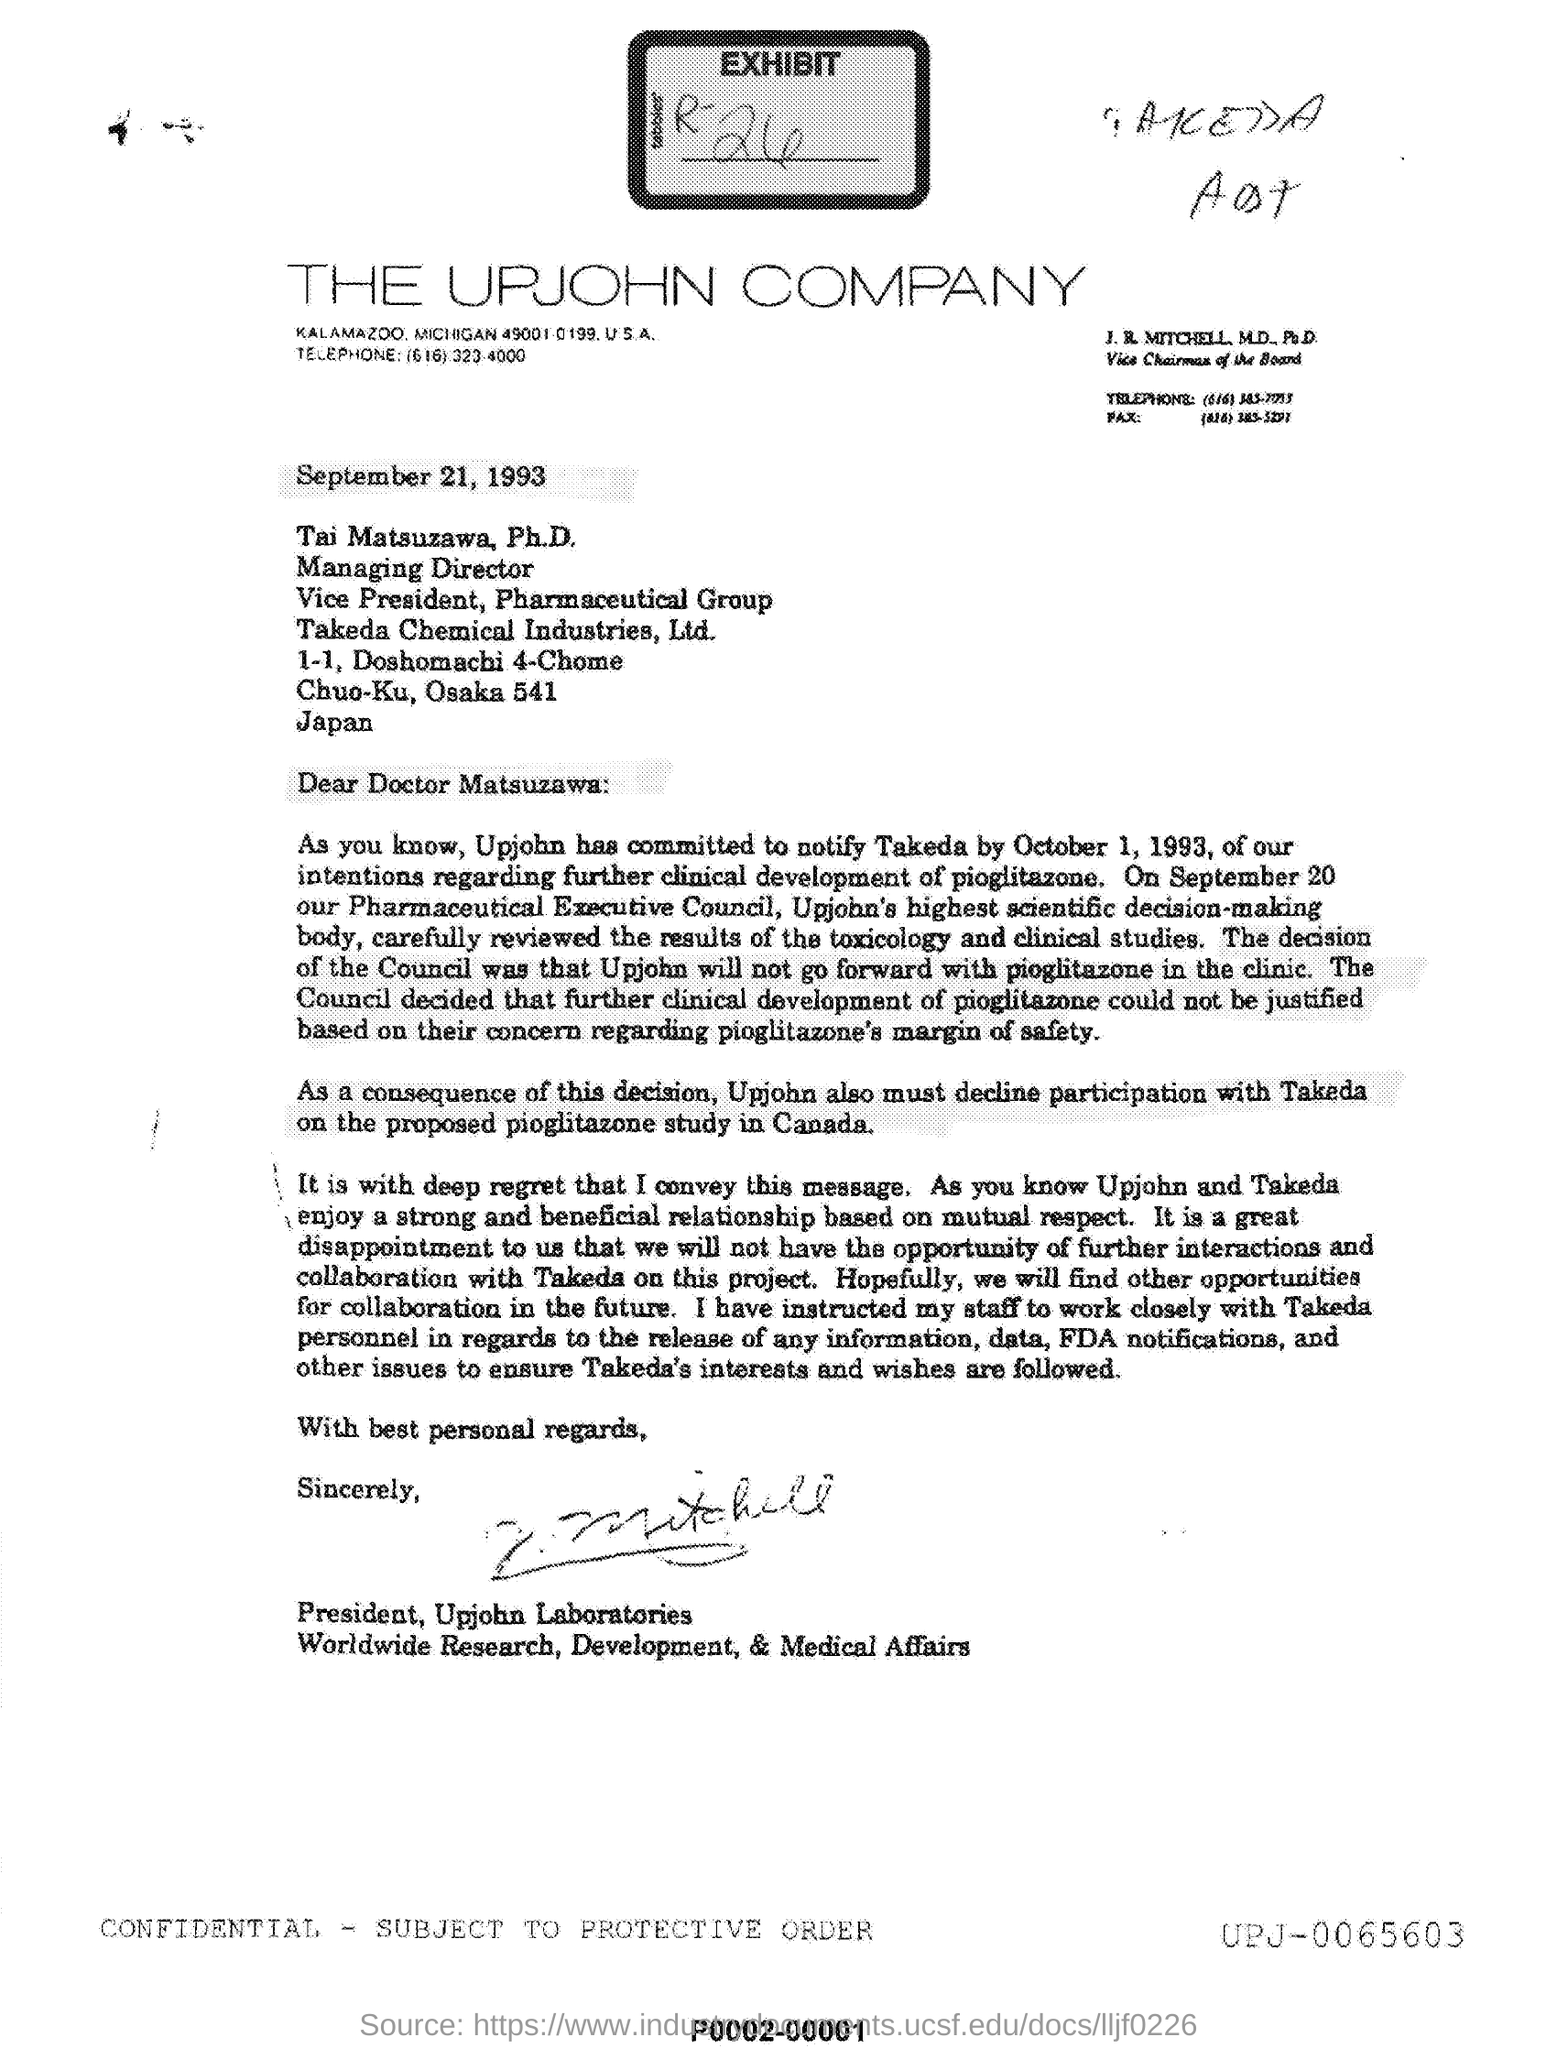What is the name of the company?
Give a very brief answer. THE UPJOHN COMPANY. What is the date mentioned?
Give a very brief answer. September 21, 1993. To whom is this letter addressed?
Provide a short and direct response. Doctor Matsuzawa. As a consequence of the decision Upjohn must decline participation with which company?
Give a very brief answer. Takeda. 